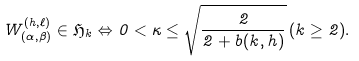Convert formula to latex. <formula><loc_0><loc_0><loc_500><loc_500>W _ { ( \alpha , \beta ) } ^ { ( h , \ell ) } \in \mathfrak { H } _ { k } \Leftrightarrow 0 < \kappa \leq \sqrt { \frac { 2 } { 2 + b ( k , h ) } } \, ( k \geq 2 ) .</formula> 